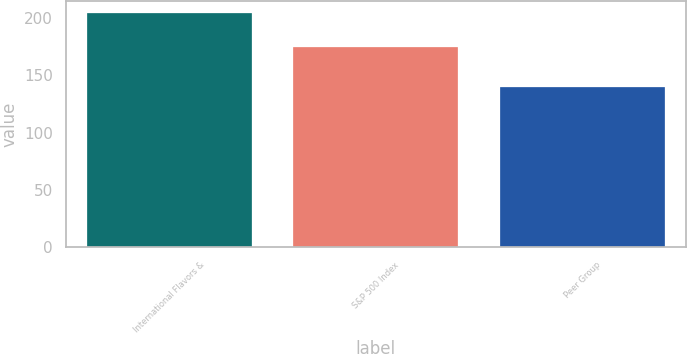<chart> <loc_0><loc_0><loc_500><loc_500><bar_chart><fcel>International Flavors &<fcel>S&P 500 Index<fcel>Peer Group<nl><fcel>204.75<fcel>174.6<fcel>140.01<nl></chart> 